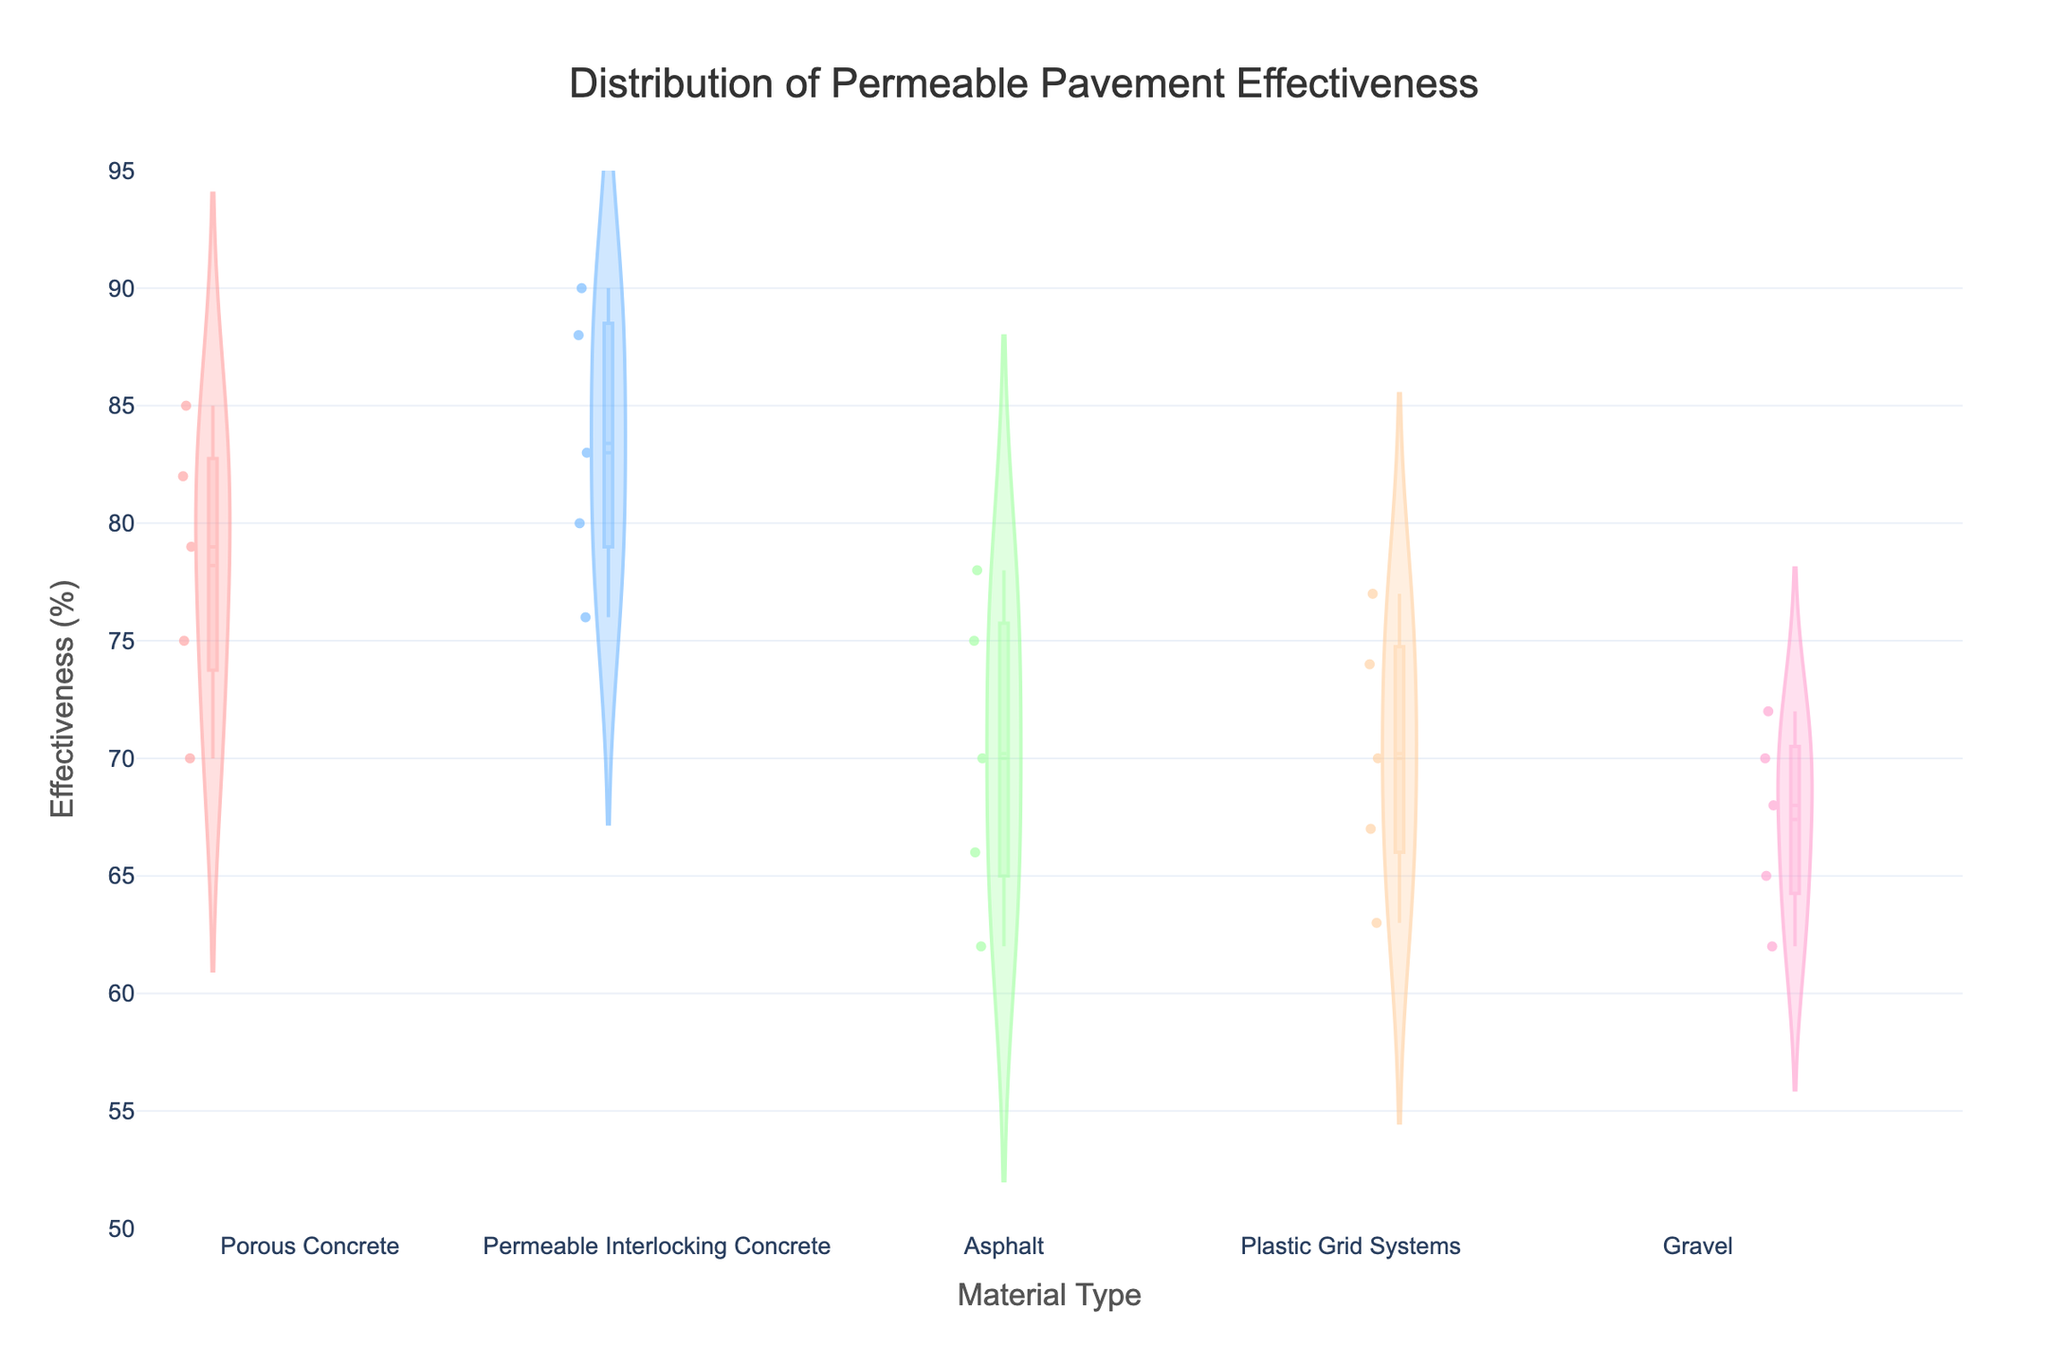What is the title of the figure? The title is located at the top center of the figure and reads: "Distribution of Permeable Pavement Effectiveness"
Answer: Distribution of Permeable Pavement Effectiveness Which material type shows the highest median effectiveness? The median effectiveness can be observed in the center line of the box plot within the violin plot. Permeable Interlocking Concrete has the highest median effectiveness as indicated by its central box line.
Answer: Permeable Interlocking Concrete What is the range of effectiveness for Porous Concrete? The range of effectiveness for Porous Concrete can be found by looking at the spread of the violin plot for this material type. Effectiveness ranges from approximately 70% to 85%.
Answer: 70% to 85% How does the effectiveness of Asphalt compare to that of Plastic Grid Systems? To compare, observe the spread and median lines of the violin plots for both materials. Both materials show a declining trend, but Plastic Grid Systems generally have slightly higher effectiveness than Asphalt across most of the range.
Answer: Plastic Grid Systems are generally more effective than Asphalt What material shows the most variability in effectiveness over time? Variability is shown as width and spread in the violin plot. Gravel, with its wide spread, indicates high variability in effectiveness.
Answer: Gravel Which material type has the lowest effectiveness at the 5-year mark? Look at the bottom of each violin plot and match it with the Installation Age values. Asphalt has the lowest effectiveness at the 5-year mark, around 62%.
Answer: Asphalt What is the median effectiveness for Plastic Grid Systems? The median effectiveness is indicated by the middle line within the box plot portion of the Plastic Grid Systems violin plot. The median effectiveness is approximately 70%.
Answer: 70% What is the effect of installation age on the effectiveness of Permeable Interlocking Concrete? The declining trend in the violin plot for each increasing age group indicates that the effectiveness of Permeable Interlocking Concrete decreases as the installation age increases.
Answer: Effectiveness decreases over time Which material type shows the smallest decrease in effectiveness over time? Compare the initial and final ends of each violin plot. Permeable Interlocking Concrete shows the smallest decrease in effectiveness over time.
Answer: Permeable Interlocking Concrete Which material type has the most consistent effectiveness? Consistency is shown by the narrow spread in the violin plot. Permeable Interlocking Concrete, with its relatively narrow spread of values, implies more consistent effectiveness.
Answer: Permeable Interlocking Concrete 